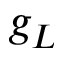<formula> <loc_0><loc_0><loc_500><loc_500>g _ { L }</formula> 